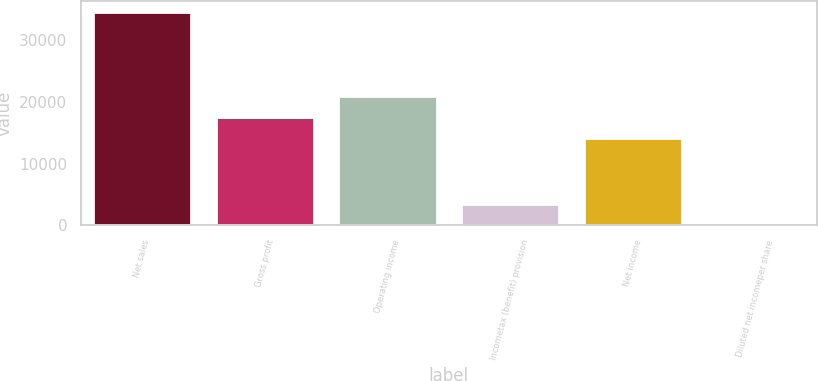Convert chart. <chart><loc_0><loc_0><loc_500><loc_500><bar_chart><fcel>Net sales<fcel>Gross profit<fcel>Operating income<fcel>Incometax (benefit) provision<fcel>Net income<fcel>Diluted net incomeper share<nl><fcel>34556<fcel>17507.6<fcel>20963.2<fcel>3455.67<fcel>14052<fcel>0.08<nl></chart> 